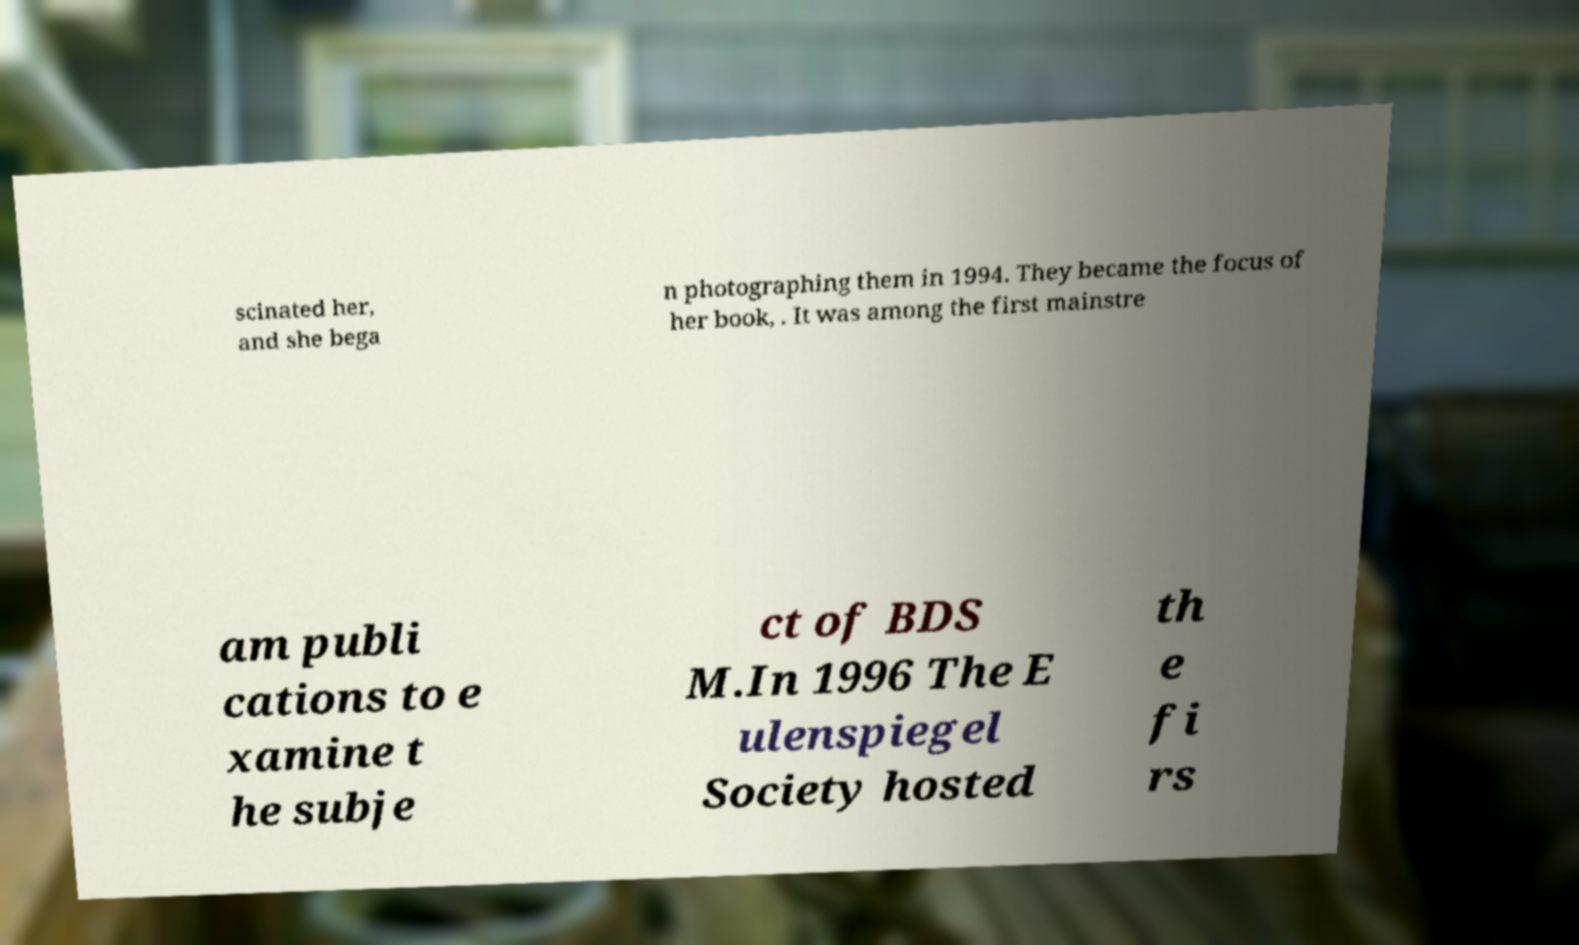What messages or text are displayed in this image? I need them in a readable, typed format. scinated her, and she bega n photographing them in 1994. They became the focus of her book, . It was among the first mainstre am publi cations to e xamine t he subje ct of BDS M.In 1996 The E ulenspiegel Society hosted th e fi rs 